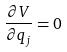<formula> <loc_0><loc_0><loc_500><loc_500>\frac { \partial V } { \partial q _ { j } } = 0</formula> 